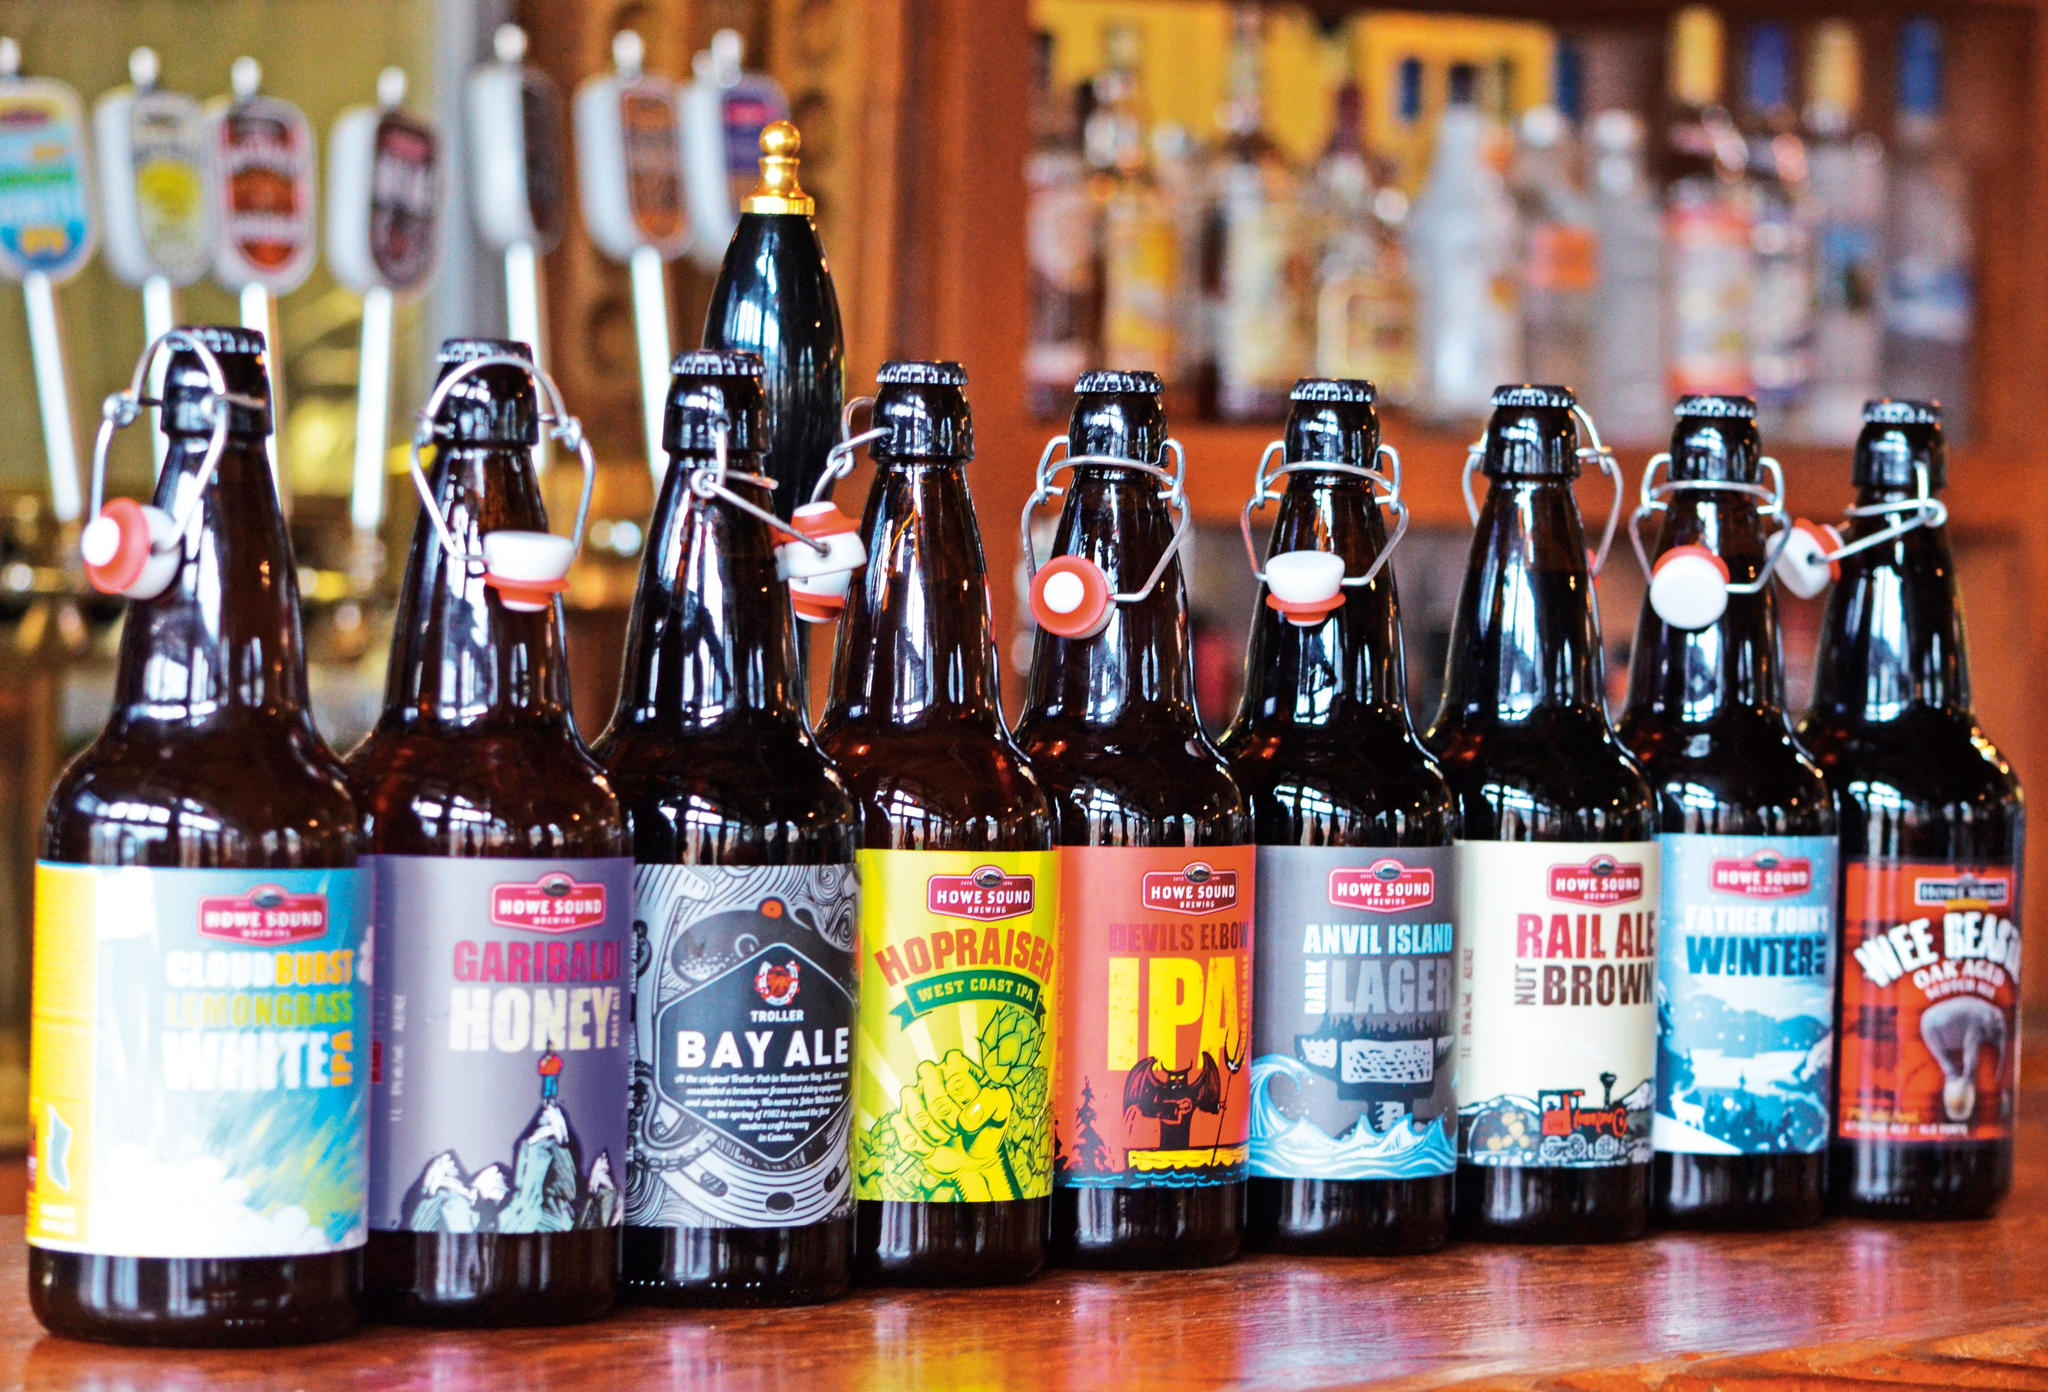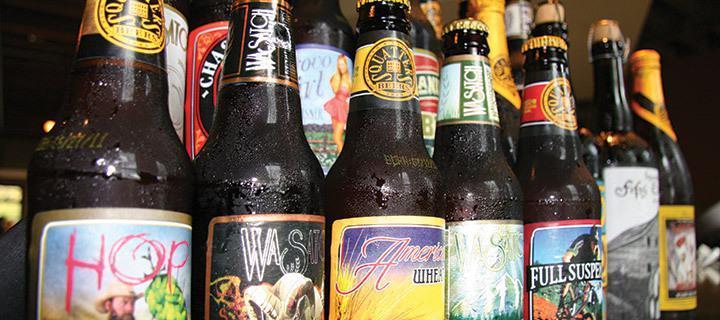The first image is the image on the left, the second image is the image on the right. For the images displayed, is the sentence "There are two levels of beer bottles." factually correct? Answer yes or no. Yes. 